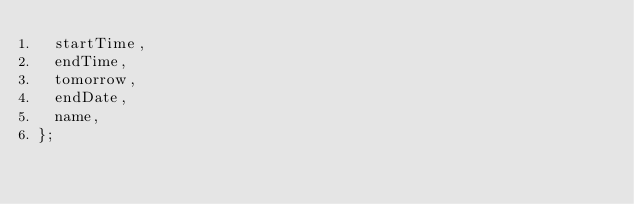Convert code to text. <code><loc_0><loc_0><loc_500><loc_500><_JavaScript_>  startTime,
  endTime,
  tomorrow,
  endDate,
  name,
};
</code> 